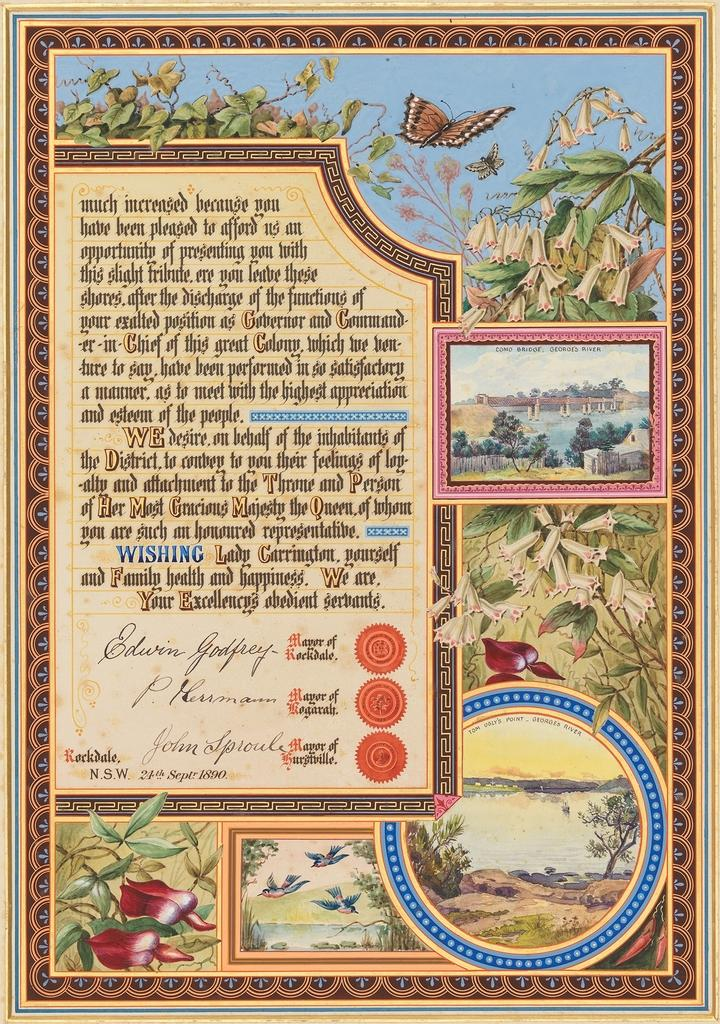<image>
Write a terse but informative summary of the picture. A poster with three different Mayor's signatures and a picture of a bridge in it labeled Como Bridge, George's River. 